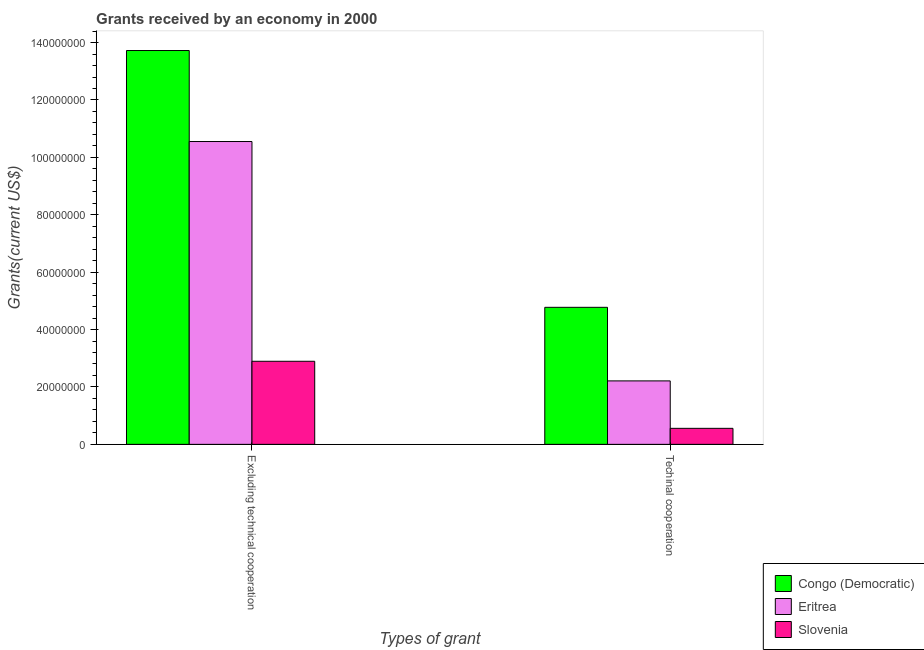How many different coloured bars are there?
Your response must be concise. 3. How many groups of bars are there?
Ensure brevity in your answer.  2. How many bars are there on the 1st tick from the left?
Provide a short and direct response. 3. How many bars are there on the 2nd tick from the right?
Offer a very short reply. 3. What is the label of the 1st group of bars from the left?
Give a very brief answer. Excluding technical cooperation. What is the amount of grants received(excluding technical cooperation) in Eritrea?
Keep it short and to the point. 1.06e+08. Across all countries, what is the maximum amount of grants received(excluding technical cooperation)?
Provide a short and direct response. 1.37e+08. Across all countries, what is the minimum amount of grants received(excluding technical cooperation)?
Your answer should be compact. 2.90e+07. In which country was the amount of grants received(excluding technical cooperation) maximum?
Your response must be concise. Congo (Democratic). In which country was the amount of grants received(excluding technical cooperation) minimum?
Ensure brevity in your answer.  Slovenia. What is the total amount of grants received(excluding technical cooperation) in the graph?
Give a very brief answer. 2.72e+08. What is the difference between the amount of grants received(including technical cooperation) in Slovenia and that in Eritrea?
Keep it short and to the point. -1.65e+07. What is the difference between the amount of grants received(excluding technical cooperation) in Congo (Democratic) and the amount of grants received(including technical cooperation) in Eritrea?
Provide a succinct answer. 1.15e+08. What is the average amount of grants received(excluding technical cooperation) per country?
Make the answer very short. 9.06e+07. What is the difference between the amount of grants received(excluding technical cooperation) and amount of grants received(including technical cooperation) in Slovenia?
Make the answer very short. 2.34e+07. What is the ratio of the amount of grants received(including technical cooperation) in Slovenia to that in Eritrea?
Provide a short and direct response. 0.25. What does the 3rd bar from the left in Techinal cooperation represents?
Ensure brevity in your answer.  Slovenia. What does the 2nd bar from the right in Excluding technical cooperation represents?
Give a very brief answer. Eritrea. What is the difference between two consecutive major ticks on the Y-axis?
Your answer should be very brief. 2.00e+07. Are the values on the major ticks of Y-axis written in scientific E-notation?
Offer a terse response. No. Does the graph contain any zero values?
Give a very brief answer. No. How many legend labels are there?
Offer a very short reply. 3. How are the legend labels stacked?
Your answer should be compact. Vertical. What is the title of the graph?
Your response must be concise. Grants received by an economy in 2000. What is the label or title of the X-axis?
Give a very brief answer. Types of grant. What is the label or title of the Y-axis?
Offer a terse response. Grants(current US$). What is the Grants(current US$) in Congo (Democratic) in Excluding technical cooperation?
Your response must be concise. 1.37e+08. What is the Grants(current US$) in Eritrea in Excluding technical cooperation?
Offer a terse response. 1.06e+08. What is the Grants(current US$) in Slovenia in Excluding technical cooperation?
Give a very brief answer. 2.90e+07. What is the Grants(current US$) in Congo (Democratic) in Techinal cooperation?
Your answer should be very brief. 4.78e+07. What is the Grants(current US$) of Eritrea in Techinal cooperation?
Provide a short and direct response. 2.21e+07. What is the Grants(current US$) in Slovenia in Techinal cooperation?
Give a very brief answer. 5.58e+06. Across all Types of grant, what is the maximum Grants(current US$) of Congo (Democratic)?
Offer a very short reply. 1.37e+08. Across all Types of grant, what is the maximum Grants(current US$) in Eritrea?
Make the answer very short. 1.06e+08. Across all Types of grant, what is the maximum Grants(current US$) of Slovenia?
Make the answer very short. 2.90e+07. Across all Types of grant, what is the minimum Grants(current US$) of Congo (Democratic)?
Your response must be concise. 4.78e+07. Across all Types of grant, what is the minimum Grants(current US$) in Eritrea?
Offer a very short reply. 2.21e+07. Across all Types of grant, what is the minimum Grants(current US$) in Slovenia?
Your answer should be very brief. 5.58e+06. What is the total Grants(current US$) of Congo (Democratic) in the graph?
Provide a short and direct response. 1.85e+08. What is the total Grants(current US$) of Eritrea in the graph?
Keep it short and to the point. 1.28e+08. What is the total Grants(current US$) in Slovenia in the graph?
Offer a very short reply. 3.45e+07. What is the difference between the Grants(current US$) in Congo (Democratic) in Excluding technical cooperation and that in Techinal cooperation?
Make the answer very short. 8.95e+07. What is the difference between the Grants(current US$) in Eritrea in Excluding technical cooperation and that in Techinal cooperation?
Your answer should be very brief. 8.34e+07. What is the difference between the Grants(current US$) in Slovenia in Excluding technical cooperation and that in Techinal cooperation?
Your answer should be very brief. 2.34e+07. What is the difference between the Grants(current US$) in Congo (Democratic) in Excluding technical cooperation and the Grants(current US$) in Eritrea in Techinal cooperation?
Your answer should be very brief. 1.15e+08. What is the difference between the Grants(current US$) of Congo (Democratic) in Excluding technical cooperation and the Grants(current US$) of Slovenia in Techinal cooperation?
Provide a succinct answer. 1.32e+08. What is the difference between the Grants(current US$) in Eritrea in Excluding technical cooperation and the Grants(current US$) in Slovenia in Techinal cooperation?
Provide a succinct answer. 9.99e+07. What is the average Grants(current US$) of Congo (Democratic) per Types of grant?
Your response must be concise. 9.25e+07. What is the average Grants(current US$) of Eritrea per Types of grant?
Your response must be concise. 6.38e+07. What is the average Grants(current US$) in Slovenia per Types of grant?
Offer a terse response. 1.73e+07. What is the difference between the Grants(current US$) in Congo (Democratic) and Grants(current US$) in Eritrea in Excluding technical cooperation?
Your answer should be very brief. 3.17e+07. What is the difference between the Grants(current US$) of Congo (Democratic) and Grants(current US$) of Slovenia in Excluding technical cooperation?
Ensure brevity in your answer.  1.08e+08. What is the difference between the Grants(current US$) in Eritrea and Grants(current US$) in Slovenia in Excluding technical cooperation?
Your answer should be compact. 7.66e+07. What is the difference between the Grants(current US$) of Congo (Democratic) and Grants(current US$) of Eritrea in Techinal cooperation?
Ensure brevity in your answer.  2.56e+07. What is the difference between the Grants(current US$) of Congo (Democratic) and Grants(current US$) of Slovenia in Techinal cooperation?
Your answer should be very brief. 4.22e+07. What is the difference between the Grants(current US$) of Eritrea and Grants(current US$) of Slovenia in Techinal cooperation?
Provide a succinct answer. 1.65e+07. What is the ratio of the Grants(current US$) of Congo (Democratic) in Excluding technical cooperation to that in Techinal cooperation?
Your response must be concise. 2.87. What is the ratio of the Grants(current US$) in Eritrea in Excluding technical cooperation to that in Techinal cooperation?
Offer a terse response. 4.77. What is the ratio of the Grants(current US$) of Slovenia in Excluding technical cooperation to that in Techinal cooperation?
Make the answer very short. 5.19. What is the difference between the highest and the second highest Grants(current US$) in Congo (Democratic)?
Provide a short and direct response. 8.95e+07. What is the difference between the highest and the second highest Grants(current US$) of Eritrea?
Provide a succinct answer. 8.34e+07. What is the difference between the highest and the second highest Grants(current US$) in Slovenia?
Ensure brevity in your answer.  2.34e+07. What is the difference between the highest and the lowest Grants(current US$) of Congo (Democratic)?
Offer a very short reply. 8.95e+07. What is the difference between the highest and the lowest Grants(current US$) of Eritrea?
Give a very brief answer. 8.34e+07. What is the difference between the highest and the lowest Grants(current US$) of Slovenia?
Your answer should be compact. 2.34e+07. 